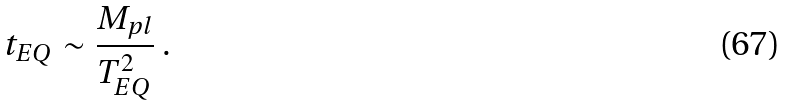<formula> <loc_0><loc_0><loc_500><loc_500>t _ { E Q } \sim \frac { M _ { p l } } { T _ { E Q } ^ { 2 } } \ .</formula> 